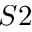<formula> <loc_0><loc_0><loc_500><loc_500>S 2</formula> 